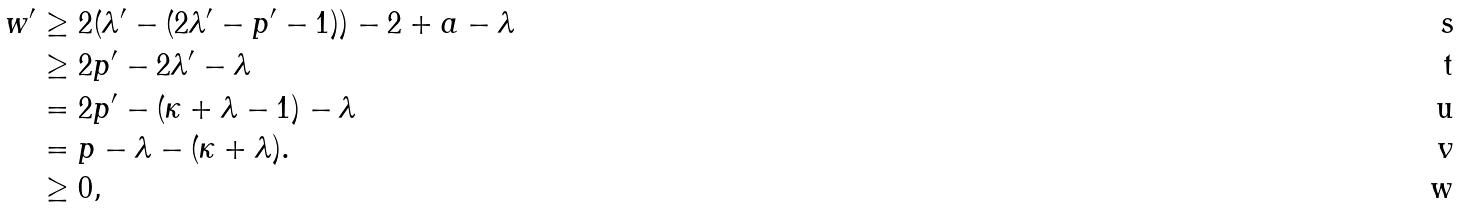Convert formula to latex. <formula><loc_0><loc_0><loc_500><loc_500>w ^ { \prime } & \geq 2 ( \lambda ^ { \prime } - ( 2 \lambda ^ { \prime } - p ^ { \prime } - 1 ) ) - 2 + a - \lambda \\ & \geq 2 p ^ { \prime } - 2 \lambda ^ { \prime } - \lambda \\ & = 2 p ^ { \prime } - ( \kappa + \lambda - 1 ) - \lambda \\ & = p - \lambda - ( \kappa + \lambda ) . \\ & \geq 0 ,</formula> 